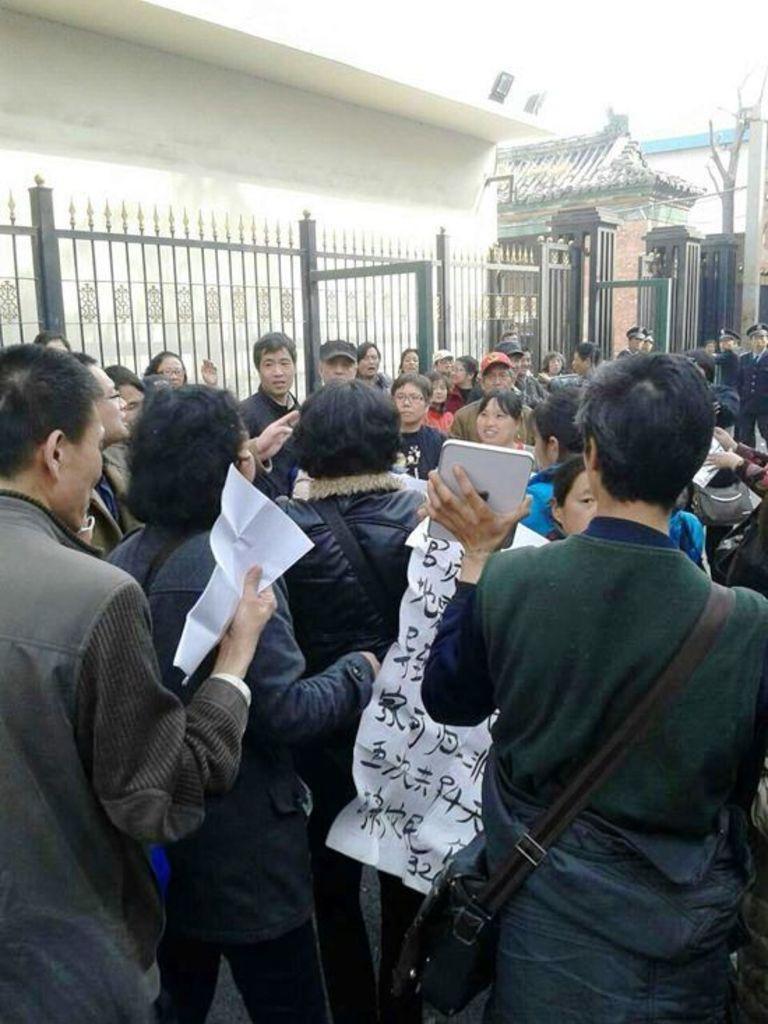Please provide a concise description of this image. In the center of the image there are people standing. In the background of the image there are houses. There is a metal fencing. 